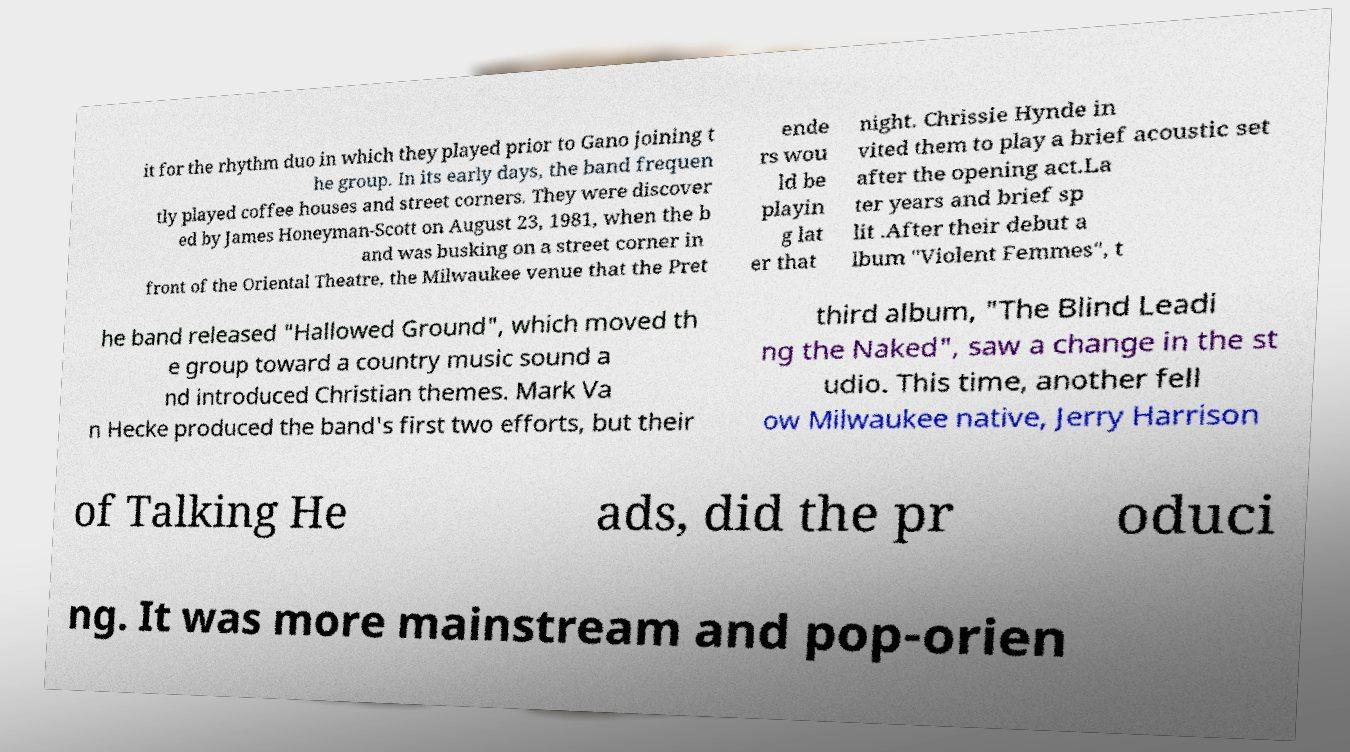Could you extract and type out the text from this image? it for the rhythm duo in which they played prior to Gano joining t he group. In its early days, the band frequen tly played coffee houses and street corners. They were discover ed by James Honeyman-Scott on August 23, 1981, when the b and was busking on a street corner in front of the Oriental Theatre, the Milwaukee venue that the Pret ende rs wou ld be playin g lat er that night. Chrissie Hynde in vited them to play a brief acoustic set after the opening act.La ter years and brief sp lit .After their debut a lbum "Violent Femmes", t he band released "Hallowed Ground", which moved th e group toward a country music sound a nd introduced Christian themes. Mark Va n Hecke produced the band's first two efforts, but their third album, "The Blind Leadi ng the Naked", saw a change in the st udio. This time, another fell ow Milwaukee native, Jerry Harrison of Talking He ads, did the pr oduci ng. It was more mainstream and pop-orien 